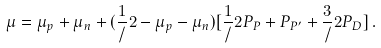<formula> <loc_0><loc_0><loc_500><loc_500>\mu = \mu _ { p } + \mu _ { n } + ( \frac { 1 } { / } 2 - \mu _ { p } - \mu _ { n } ) [ \frac { 1 } { / } 2 P _ { P } + P _ { P ^ { \prime } } + \frac { 3 } { / } 2 P _ { D } ] \, .</formula> 